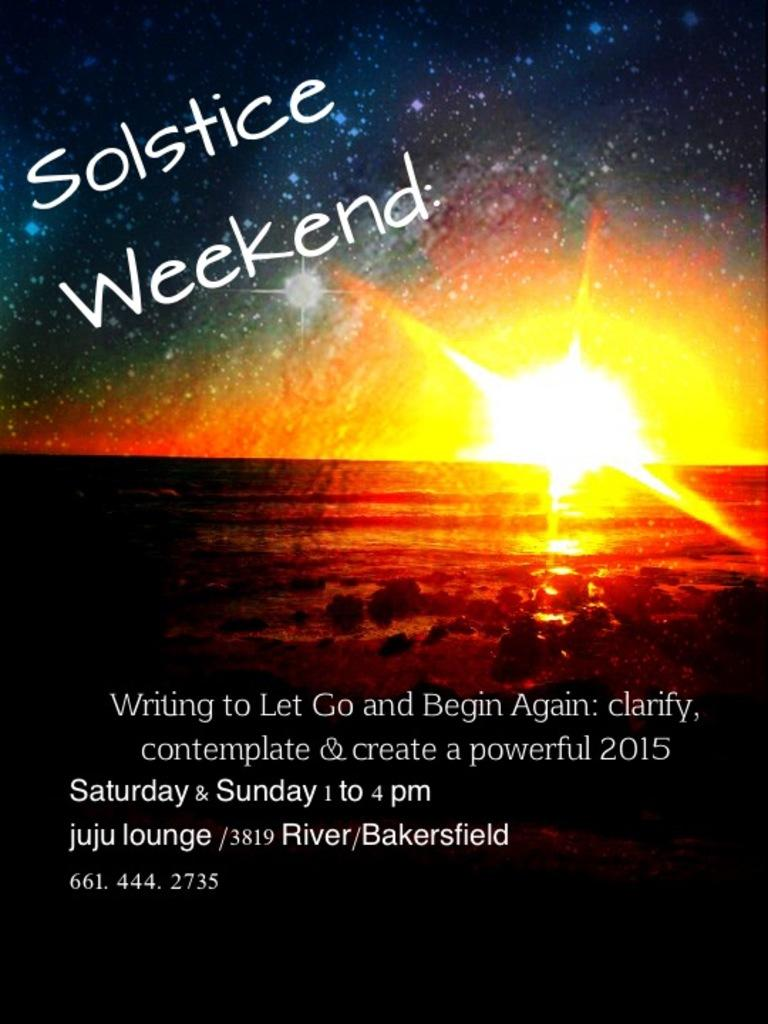<image>
Relay a brief, clear account of the picture shown. a poster of a sunset that says 'solstice weekend' on it 